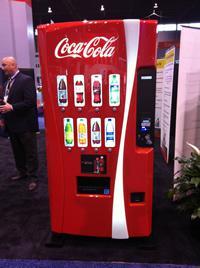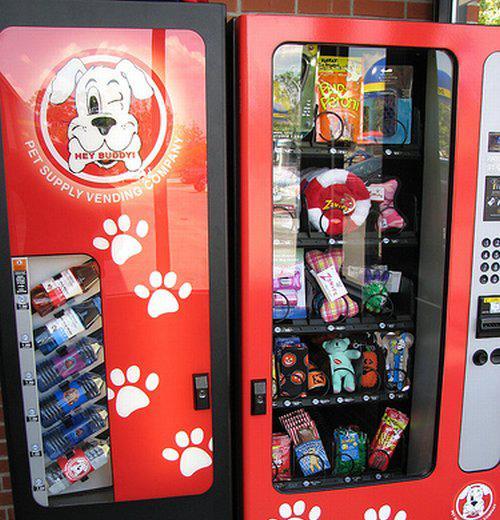The first image is the image on the left, the second image is the image on the right. For the images displayed, is the sentence "In one of the images, there are three machines." factually correct? Answer yes or no. No. The first image is the image on the left, the second image is the image on the right. Evaluate the accuracy of this statement regarding the images: "1 vending machine is the traditional closed-face, single image, cover.". Is it true? Answer yes or no. No. 